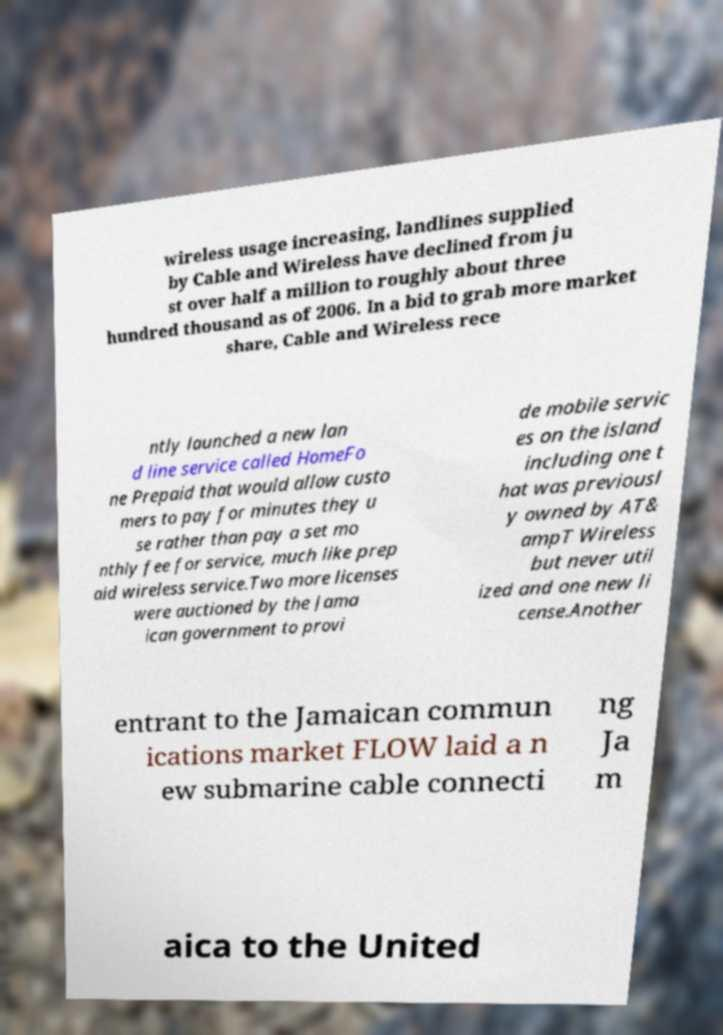I need the written content from this picture converted into text. Can you do that? wireless usage increasing, landlines supplied by Cable and Wireless have declined from ju st over half a million to roughly about three hundred thousand as of 2006. In a bid to grab more market share, Cable and Wireless rece ntly launched a new lan d line service called HomeFo ne Prepaid that would allow custo mers to pay for minutes they u se rather than pay a set mo nthly fee for service, much like prep aid wireless service.Two more licenses were auctioned by the Jama ican government to provi de mobile servic es on the island including one t hat was previousl y owned by AT& ampT Wireless but never util ized and one new li cense.Another entrant to the Jamaican commun ications market FLOW laid a n ew submarine cable connecti ng Ja m aica to the United 